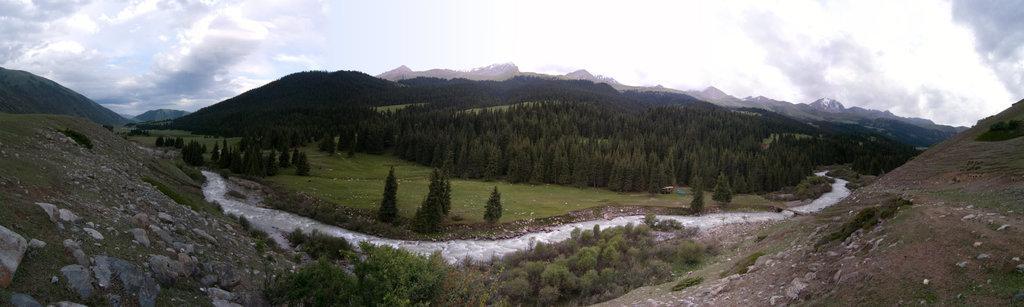How would you summarize this image in a sentence or two? In this picture I can see rocks, water, trees, hills, and in the background there is sky. 